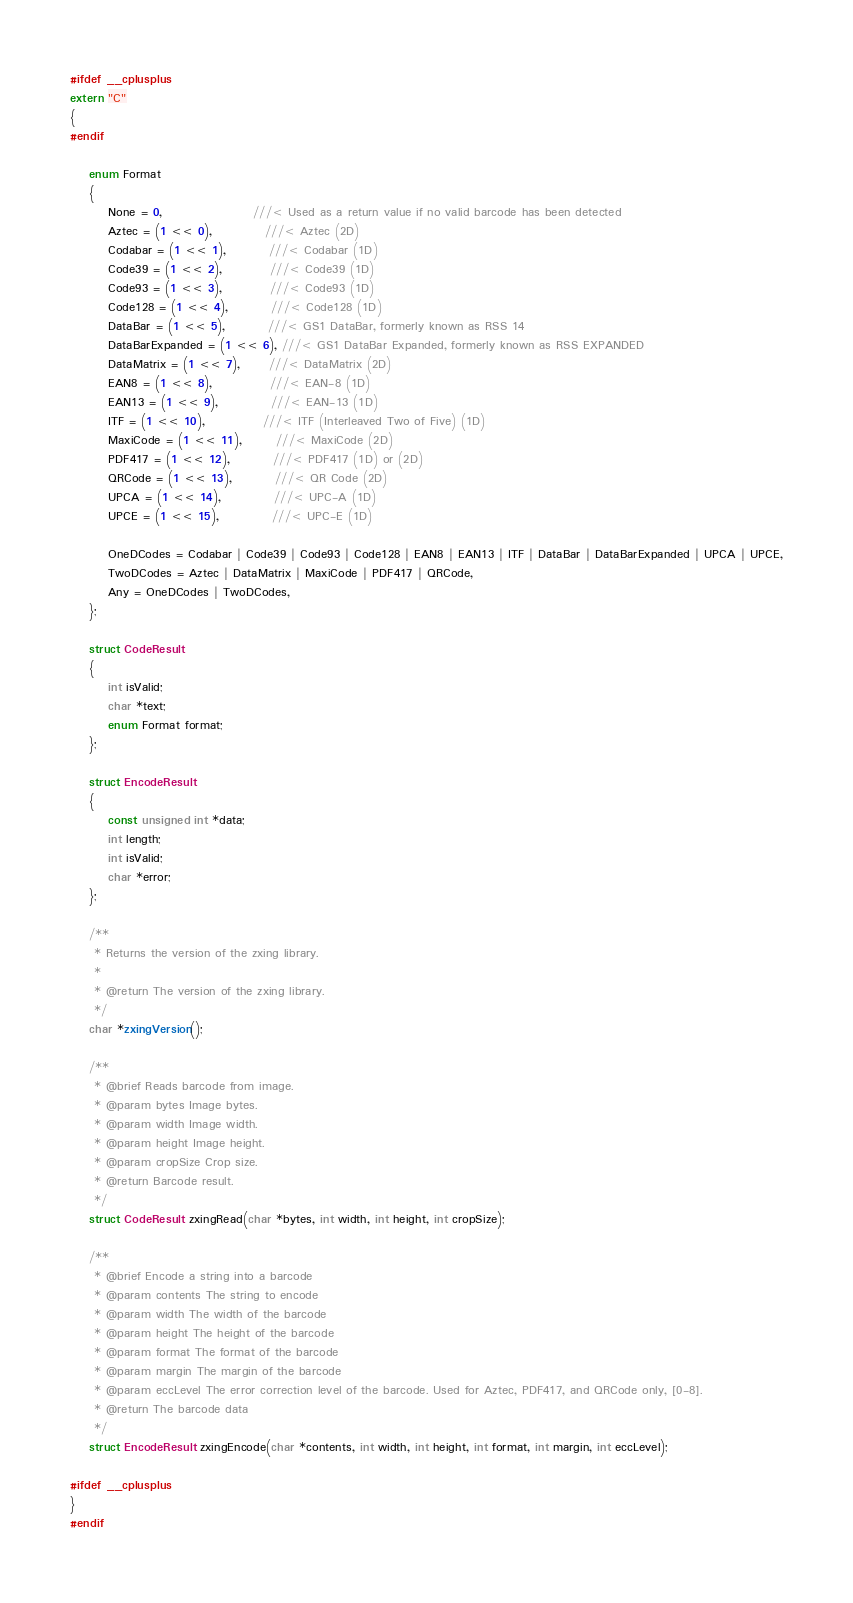<code> <loc_0><loc_0><loc_500><loc_500><_C_>#ifdef __cplusplus
extern "C"
{
#endif

    enum Format
    {
        None = 0,                   ///< Used as a return value if no valid barcode has been detected
        Aztec = (1 << 0),           ///< Aztec (2D)
        Codabar = (1 << 1),         ///< Codabar (1D)
        Code39 = (1 << 2),          ///< Code39 (1D)
        Code93 = (1 << 3),          ///< Code93 (1D)
        Code128 = (1 << 4),         ///< Code128 (1D)
        DataBar = (1 << 5),         ///< GS1 DataBar, formerly known as RSS 14
        DataBarExpanded = (1 << 6), ///< GS1 DataBar Expanded, formerly known as RSS EXPANDED
        DataMatrix = (1 << 7),      ///< DataMatrix (2D)
        EAN8 = (1 << 8),            ///< EAN-8 (1D)
        EAN13 = (1 << 9),           ///< EAN-13 (1D)
        ITF = (1 << 10),            ///< ITF (Interleaved Two of Five) (1D)
        MaxiCode = (1 << 11),       ///< MaxiCode (2D)
        PDF417 = (1 << 12),         ///< PDF417 (1D) or (2D)
        QRCode = (1 << 13),         ///< QR Code (2D)
        UPCA = (1 << 14),           ///< UPC-A (1D)
        UPCE = (1 << 15),           ///< UPC-E (1D)

        OneDCodes = Codabar | Code39 | Code93 | Code128 | EAN8 | EAN13 | ITF | DataBar | DataBarExpanded | UPCA | UPCE,
        TwoDCodes = Aztec | DataMatrix | MaxiCode | PDF417 | QRCode,
        Any = OneDCodes | TwoDCodes,
    };

    struct CodeResult
    {
        int isValid;
        char *text;
        enum Format format;
    };

    struct EncodeResult
    {
        const unsigned int *data;
        int length;
        int isValid;
        char *error;
    };

    /**
     * Returns the version of the zxing library.
     *
     * @return The version of the zxing library.
     */
    char *zxingVersion();

    /**
     * @brief Reads barcode from image.
     * @param bytes Image bytes.
     * @param width Image width.
     * @param height Image height.
     * @param cropSize Crop size.
     * @return Barcode result.
     */
    struct CodeResult zxingRead(char *bytes, int width, int height, int cropSize);

    /**
     * @brief Encode a string into a barcode
     * @param contents The string to encode
     * @param width The width of the barcode
     * @param height The height of the barcode
     * @param format The format of the barcode
     * @param margin The margin of the barcode
     * @param eccLevel The error correction level of the barcode. Used for Aztec, PDF417, and QRCode only, [0-8].
     * @return The barcode data
     */
    struct EncodeResult zxingEncode(char *contents, int width, int height, int format, int margin, int eccLevel);

#ifdef __cplusplus
}
#endif</code> 